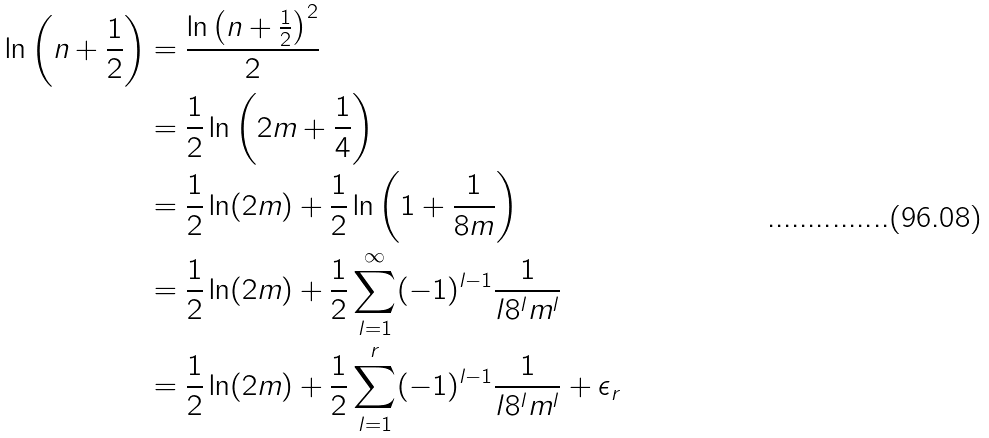<formula> <loc_0><loc_0><loc_500><loc_500>\ln \left ( n + \frac { 1 } { 2 } \right ) & = \frac { \ln \left ( n + \frac { 1 } { 2 } \right ) ^ { 2 } } { 2 } \\ & = \frac { 1 } { 2 } \ln \left ( 2 m + \frac { 1 } { 4 } \right ) \\ & = \frac { 1 } { 2 } \ln ( 2 m ) + \frac { 1 } { 2 } \ln \left ( 1 + \frac { 1 } { 8 m } \right ) \\ & = \frac { 1 } { 2 } \ln ( 2 m ) + \frac { 1 } { 2 } \sum _ { l = 1 } ^ { \infty } ( - 1 ) ^ { l - 1 } \frac { 1 } { l 8 ^ { l } m ^ { l } } \\ & = \frac { 1 } { 2 } \ln ( 2 m ) + \frac { 1 } { 2 } \sum _ { l = 1 } ^ { r } ( - 1 ) ^ { l - 1 } \frac { 1 } { l 8 ^ { l } m ^ { l } } + \epsilon _ { r } \\</formula> 